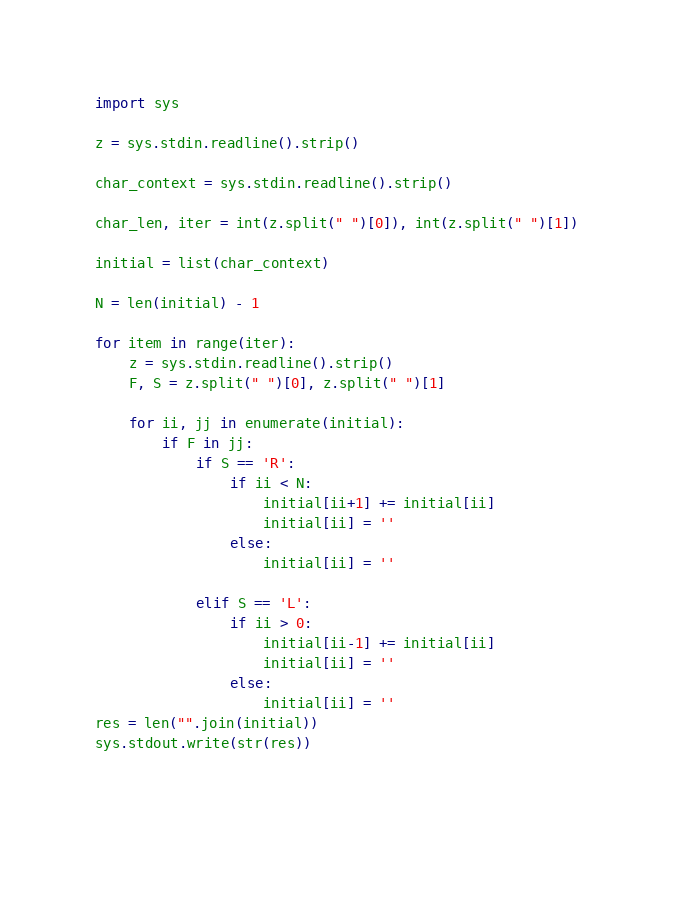Convert code to text. <code><loc_0><loc_0><loc_500><loc_500><_Python_>import sys

z = sys.stdin.readline().strip()

char_context = sys.stdin.readline().strip()

char_len, iter = int(z.split(" ")[0]), int(z.split(" ")[1])

initial = list(char_context)

N = len(initial) - 1

for item in range(iter):
    z = sys.stdin.readline().strip()
    F, S = z.split(" ")[0], z.split(" ")[1]

    for ii, jj in enumerate(initial):
        if F in jj:
            if S == 'R':
                if ii < N:
                    initial[ii+1] += initial[ii]
                    initial[ii] = ''
                else:
                    initial[ii] = ''

            elif S == 'L':
                if ii > 0:
                    initial[ii-1] += initial[ii]
                    initial[ii] = ''
                else:
                    initial[ii] = ''
res = len("".join(initial))
sys.stdout.write(str(res))
  
  
  

</code> 